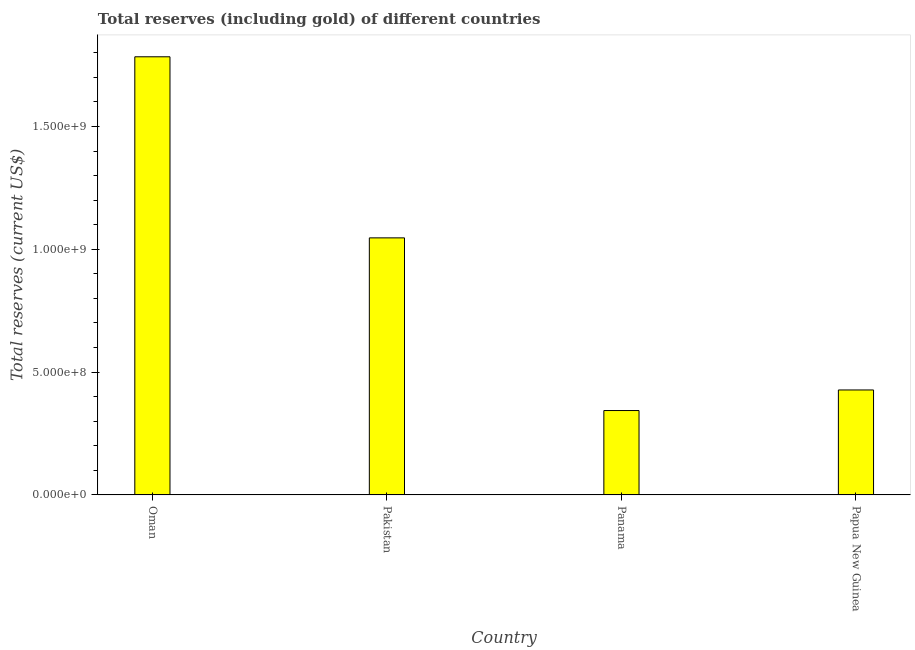What is the title of the graph?
Give a very brief answer. Total reserves (including gold) of different countries. What is the label or title of the Y-axis?
Ensure brevity in your answer.  Total reserves (current US$). What is the total reserves (including gold) in Papua New Guinea?
Provide a succinct answer. 4.27e+08. Across all countries, what is the maximum total reserves (including gold)?
Keep it short and to the point. 1.78e+09. Across all countries, what is the minimum total reserves (including gold)?
Your answer should be very brief. 3.44e+08. In which country was the total reserves (including gold) maximum?
Provide a short and direct response. Oman. In which country was the total reserves (including gold) minimum?
Give a very brief answer. Panama. What is the sum of the total reserves (including gold)?
Your answer should be very brief. 3.60e+09. What is the difference between the total reserves (including gold) in Pakistan and Papua New Guinea?
Offer a very short reply. 6.19e+08. What is the average total reserves (including gold) per country?
Your answer should be compact. 9.00e+08. What is the median total reserves (including gold)?
Make the answer very short. 7.37e+08. In how many countries, is the total reserves (including gold) greater than 1300000000 US$?
Your answer should be compact. 1. What is the ratio of the total reserves (including gold) in Pakistan to that in Panama?
Offer a terse response. 3.05. Is the total reserves (including gold) in Pakistan less than that in Papua New Guinea?
Offer a very short reply. No. What is the difference between the highest and the second highest total reserves (including gold)?
Provide a succinct answer. 7.37e+08. What is the difference between the highest and the lowest total reserves (including gold)?
Your answer should be very brief. 1.44e+09. How many bars are there?
Provide a succinct answer. 4. What is the Total reserves (current US$) of Oman?
Make the answer very short. 1.78e+09. What is the Total reserves (current US$) in Pakistan?
Keep it short and to the point. 1.05e+09. What is the Total reserves (current US$) in Panama?
Offer a terse response. 3.44e+08. What is the Total reserves (current US$) of Papua New Guinea?
Your answer should be very brief. 4.27e+08. What is the difference between the Total reserves (current US$) in Oman and Pakistan?
Give a very brief answer. 7.37e+08. What is the difference between the Total reserves (current US$) in Oman and Panama?
Your response must be concise. 1.44e+09. What is the difference between the Total reserves (current US$) in Oman and Papua New Guinea?
Provide a succinct answer. 1.36e+09. What is the difference between the Total reserves (current US$) in Pakistan and Panama?
Provide a short and direct response. 7.03e+08. What is the difference between the Total reserves (current US$) in Pakistan and Papua New Guinea?
Your response must be concise. 6.19e+08. What is the difference between the Total reserves (current US$) in Panama and Papua New Guinea?
Offer a terse response. -8.38e+07. What is the ratio of the Total reserves (current US$) in Oman to that in Pakistan?
Provide a succinct answer. 1.7. What is the ratio of the Total reserves (current US$) in Oman to that in Panama?
Offer a terse response. 5.19. What is the ratio of the Total reserves (current US$) in Oman to that in Papua New Guinea?
Give a very brief answer. 4.17. What is the ratio of the Total reserves (current US$) in Pakistan to that in Panama?
Your answer should be very brief. 3.05. What is the ratio of the Total reserves (current US$) in Pakistan to that in Papua New Guinea?
Offer a very short reply. 2.45. What is the ratio of the Total reserves (current US$) in Panama to that in Papua New Guinea?
Your response must be concise. 0.8. 